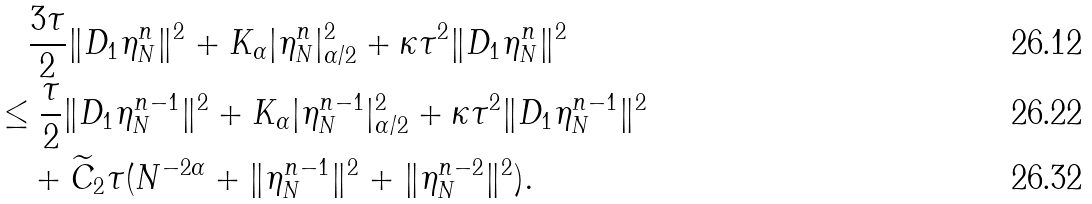<formula> <loc_0><loc_0><loc_500><loc_500>& \quad \frac { 3 \tau } { 2 } \| D _ { 1 } \eta _ { N } ^ { n } \| ^ { 2 } + { K _ { \alpha } } | \eta _ { N } ^ { n } | ^ { 2 } _ { \alpha / 2 } + \kappa \tau ^ { 2 } \| D _ { 1 } \eta _ { N } ^ { n } \| ^ { 2 } \\ & \leq \frac { \tau } { 2 } \| D _ { 1 } \eta _ { N } ^ { n - 1 } \| ^ { 2 } + K _ { \alpha } | \eta ^ { n - 1 } _ { N } | _ { \alpha / 2 } ^ { 2 } + \kappa \tau ^ { 2 } \| D _ { 1 } \eta _ { N } ^ { n - 1 } \| ^ { 2 } \\ & \quad + \widetilde { C } _ { 2 } \tau ( N ^ { - 2 \alpha } + \| \eta _ { N } ^ { n - 1 } \| ^ { 2 } + \| \eta _ { N } ^ { n - 2 } \| ^ { 2 } ) .</formula> 